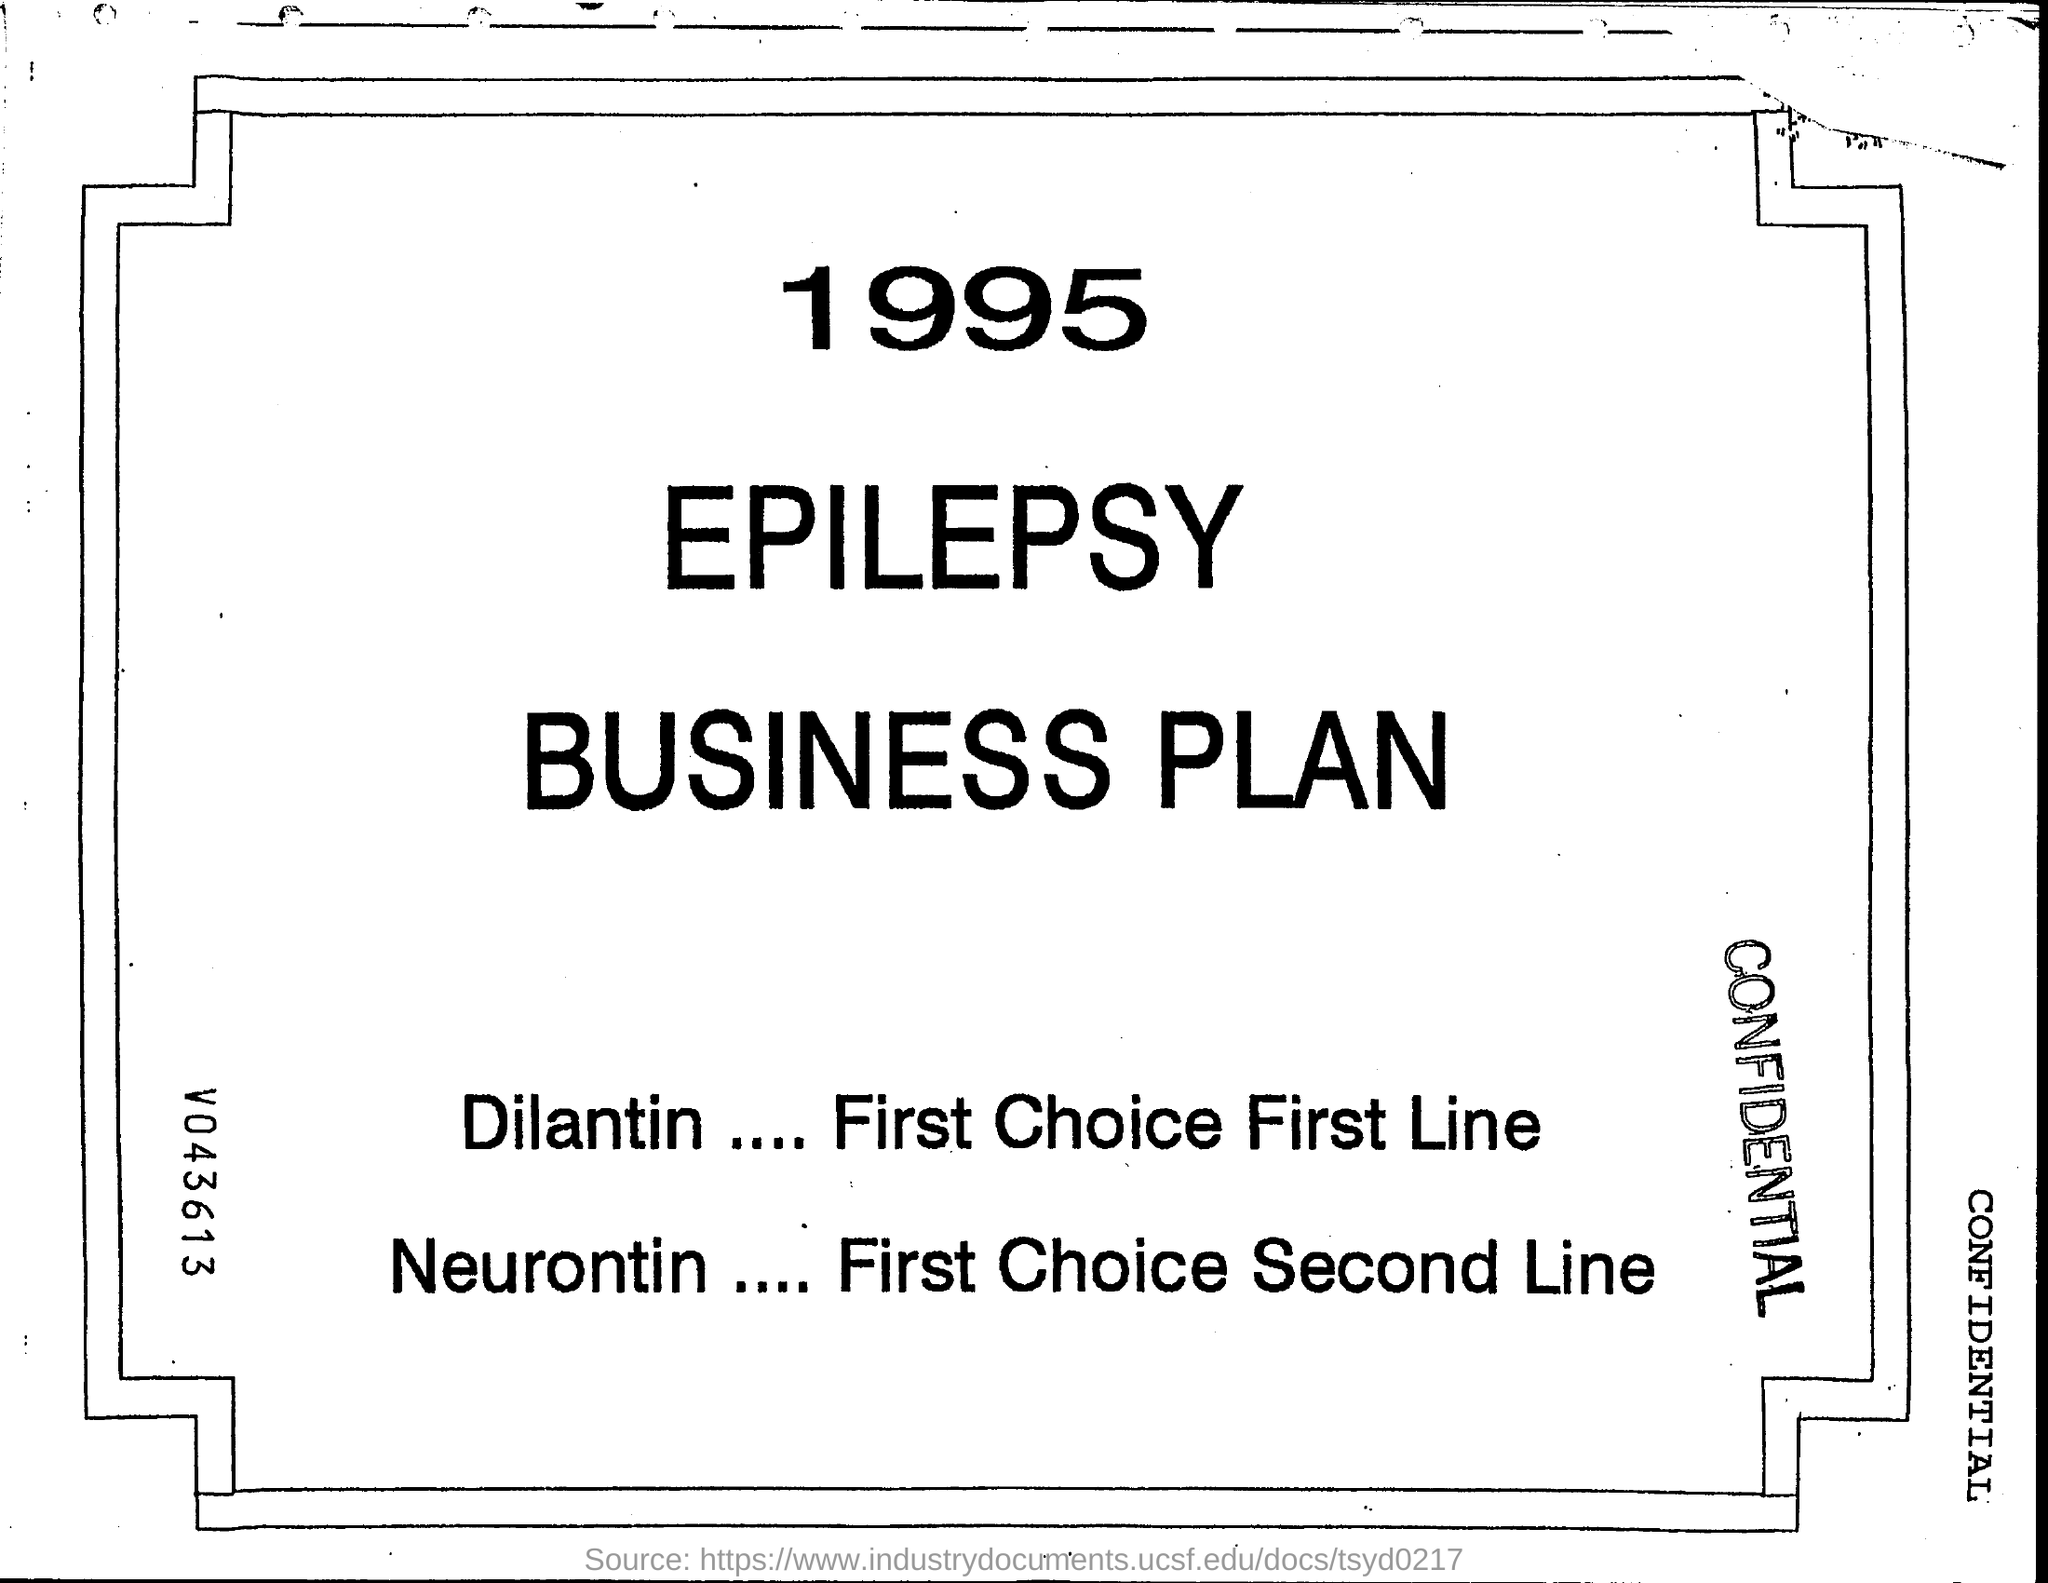Give some essential details in this illustration. First Choice Second Line is a medication called Neurontin. First choice first line is dilantin. 